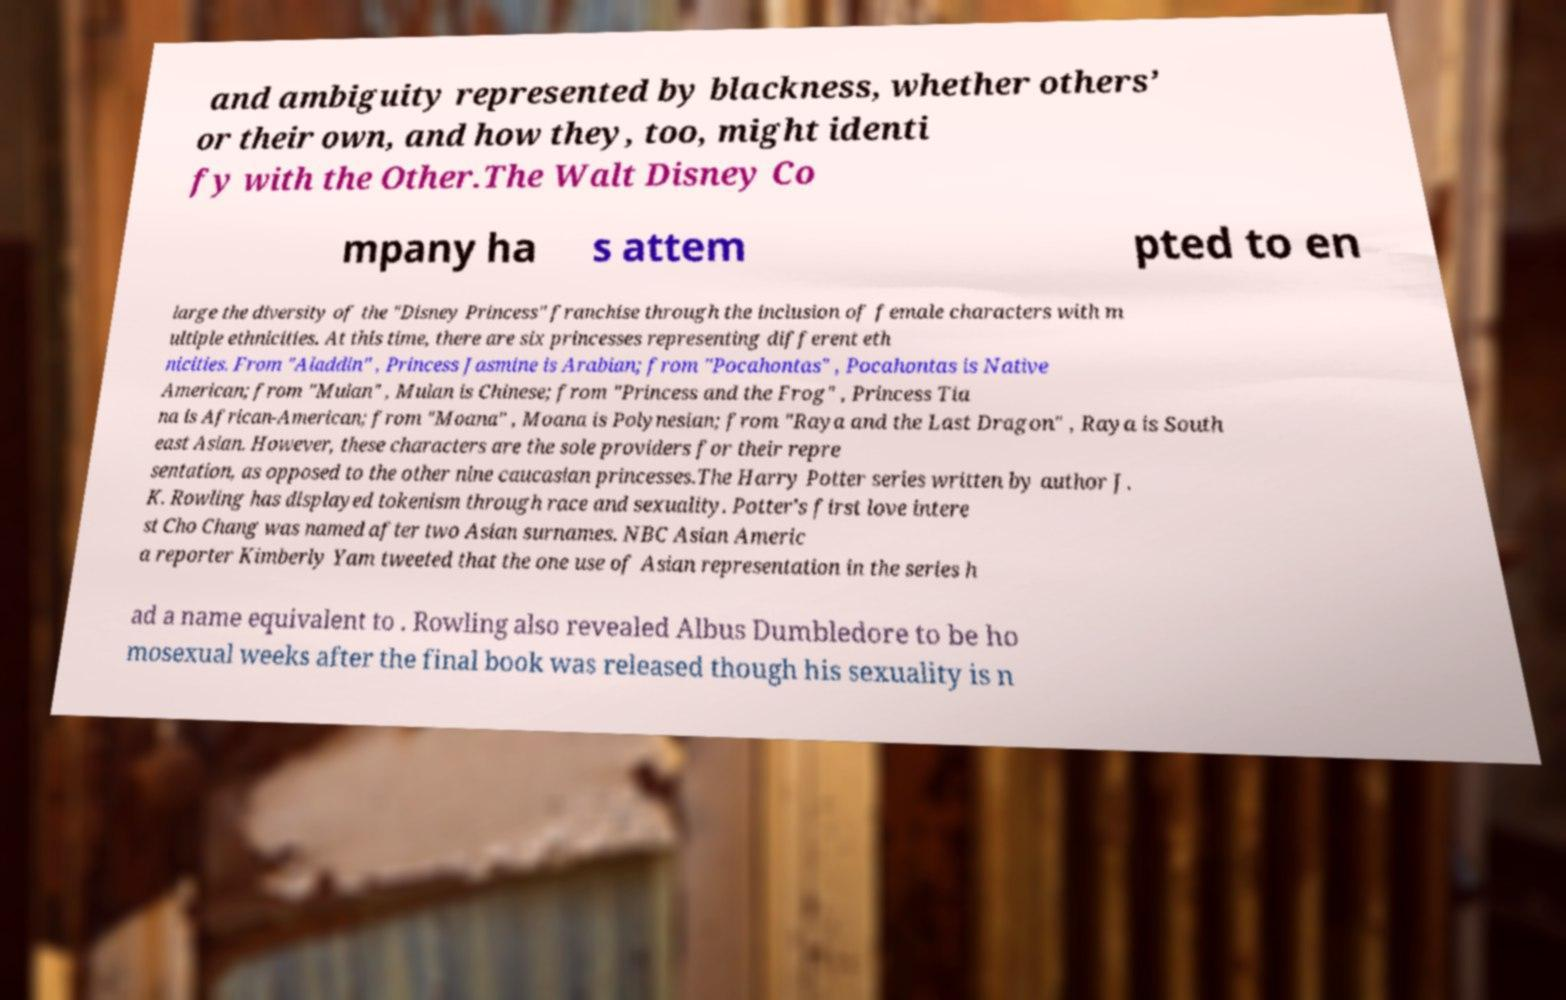Please read and relay the text visible in this image. What does it say? and ambiguity represented by blackness, whether others’ or their own, and how they, too, might identi fy with the Other.The Walt Disney Co mpany ha s attem pted to en large the diversity of the "Disney Princess" franchise through the inclusion of female characters with m ultiple ethnicities. At this time, there are six princesses representing different eth nicities. From "Aladdin" , Princess Jasmine is Arabian; from "Pocahontas" , Pocahontas is Native American; from "Mulan" , Mulan is Chinese; from "Princess and the Frog" , Princess Tia na is African-American; from "Moana" , Moana is Polynesian; from "Raya and the Last Dragon" , Raya is South east Asian. However, these characters are the sole providers for their repre sentation, as opposed to the other nine caucasian princesses.The Harry Potter series written by author J. K. Rowling has displayed tokenism through race and sexuality. Potter’s first love intere st Cho Chang was named after two Asian surnames. NBC Asian Americ a reporter Kimberly Yam tweeted that the one use of Asian representation in the series h ad a name equivalent to . Rowling also revealed Albus Dumbledore to be ho mosexual weeks after the final book was released though his sexuality is n 